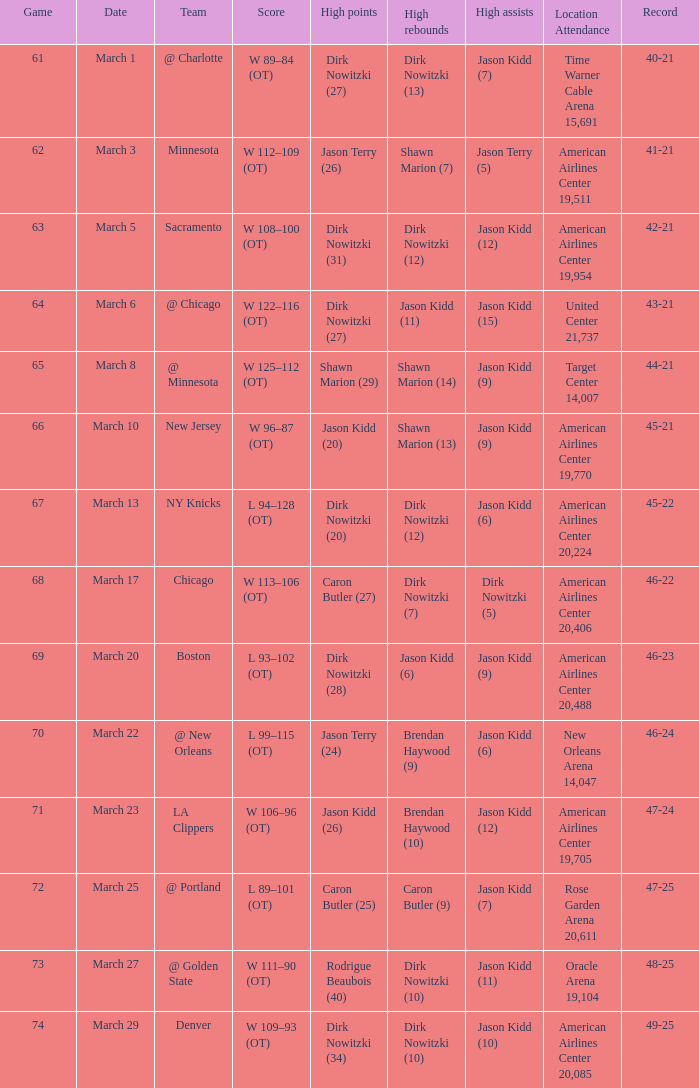List the stadium and number of people in attendance when the team record was 45-22. 1.0. 